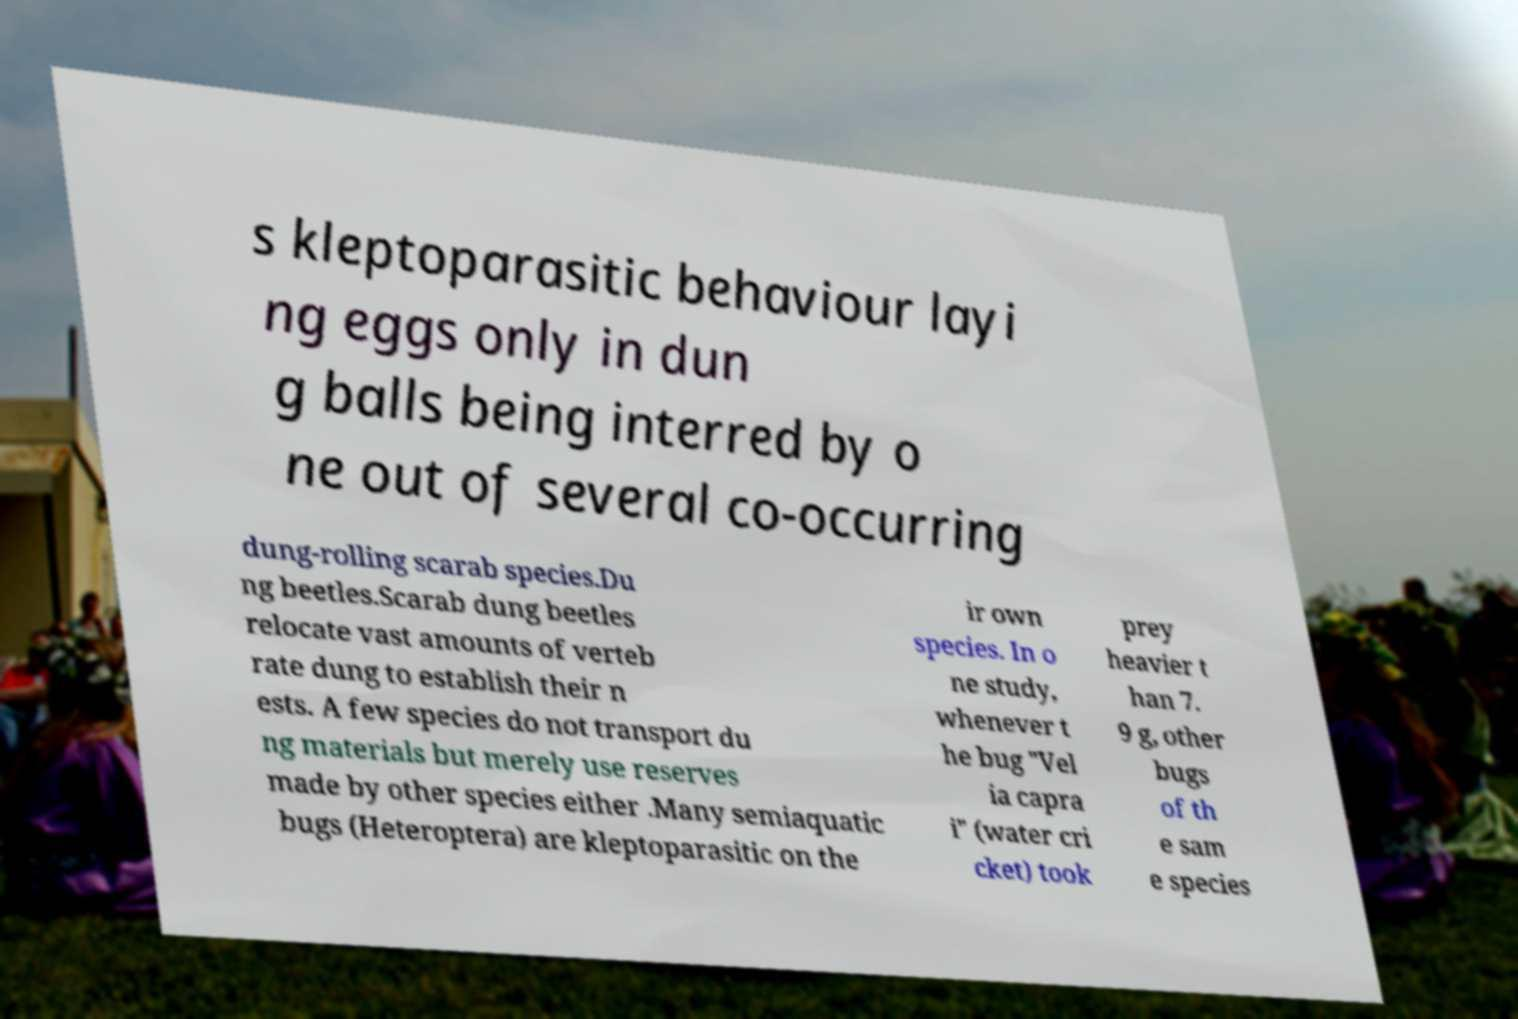Could you assist in decoding the text presented in this image and type it out clearly? s kleptoparasitic behaviour layi ng eggs only in dun g balls being interred by o ne out of several co-occurring dung-rolling scarab species.Du ng beetles.Scarab dung beetles relocate vast amounts of verteb rate dung to establish their n ests. A few species do not transport du ng materials but merely use reserves made by other species either .Many semiaquatic bugs (Heteroptera) are kleptoparasitic on the ir own species. In o ne study, whenever t he bug "Vel ia capra i" (water cri cket) took prey heavier t han 7. 9 g, other bugs of th e sam e species 